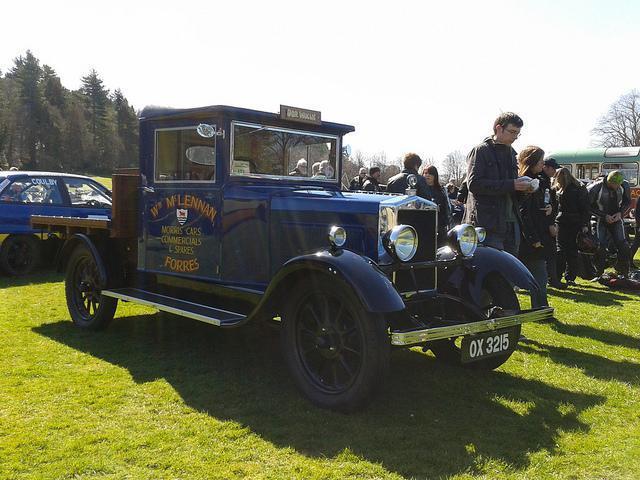How many people are in the picture?
Give a very brief answer. 4. 